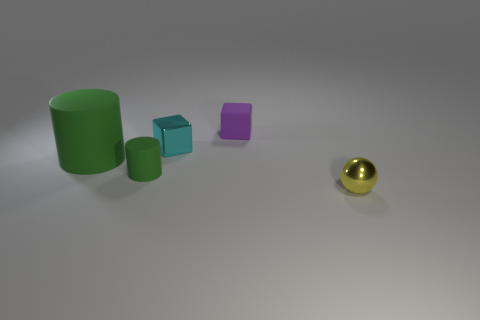How many big things have the same shape as the tiny green thing?
Give a very brief answer. 1. There is a large thing that is the same material as the purple cube; what is its shape?
Provide a short and direct response. Cylinder. The tiny metallic object in front of the tiny metal thing that is behind the tiny yellow thing is what color?
Offer a terse response. Yellow. Does the large rubber cylinder have the same color as the small rubber cylinder?
Ensure brevity in your answer.  Yes. The ball in front of the cylinder that is behind the small cylinder is made of what material?
Keep it short and to the point. Metal. There is another thing that is the same shape as the purple matte object; what material is it?
Your answer should be very brief. Metal. There is a matte cylinder behind the cylinder that is in front of the big green cylinder; is there a tiny cyan thing behind it?
Give a very brief answer. Yes. How many other things are there of the same color as the large object?
Make the answer very short. 1. What number of objects are behind the ball and to the right of the tiny matte cylinder?
Your response must be concise. 2. What is the shape of the tiny green object?
Give a very brief answer. Cylinder. 